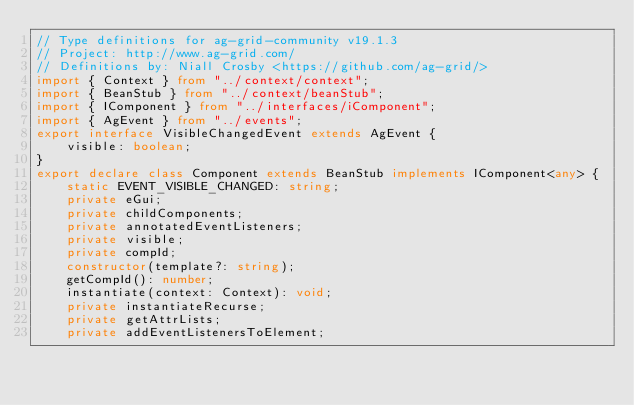Convert code to text. <code><loc_0><loc_0><loc_500><loc_500><_TypeScript_>// Type definitions for ag-grid-community v19.1.3
// Project: http://www.ag-grid.com/
// Definitions by: Niall Crosby <https://github.com/ag-grid/>
import { Context } from "../context/context";
import { BeanStub } from "../context/beanStub";
import { IComponent } from "../interfaces/iComponent";
import { AgEvent } from "../events";
export interface VisibleChangedEvent extends AgEvent {
    visible: boolean;
}
export declare class Component extends BeanStub implements IComponent<any> {
    static EVENT_VISIBLE_CHANGED: string;
    private eGui;
    private childComponents;
    private annotatedEventListeners;
    private visible;
    private compId;
    constructor(template?: string);
    getCompId(): number;
    instantiate(context: Context): void;
    private instantiateRecurse;
    private getAttrLists;
    private addEventListenersToElement;</code> 